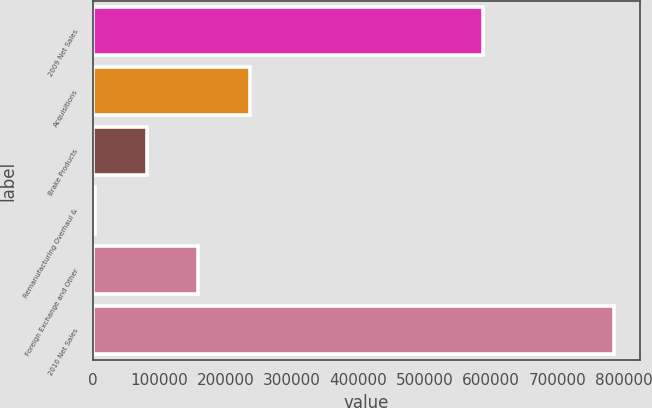<chart> <loc_0><loc_0><loc_500><loc_500><bar_chart><fcel>2009 Net Sales<fcel>Acquisitions<fcel>Brake Products<fcel>Remanufacturing Overhaul &<fcel>Foreign Exchange and Other<fcel>2010 Net Sales<nl><fcel>588399<fcel>237472<fcel>81176.5<fcel>3029<fcel>159324<fcel>784504<nl></chart> 